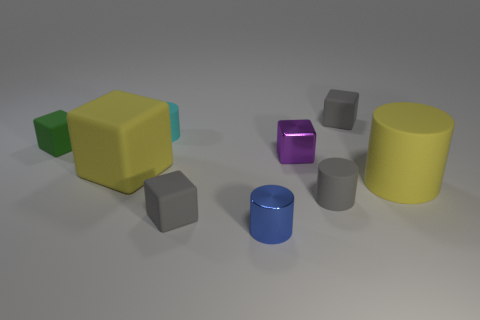There is a matte object that is the same color as the large block; what is its shape?
Your response must be concise. Cylinder. The block that is the same color as the big cylinder is what size?
Your answer should be compact. Large. There is a yellow rubber object on the right side of the cyan matte cylinder; what number of small gray rubber objects are behind it?
Your answer should be compact. 1. Is the shape of the purple object the same as the green object?
Make the answer very short. Yes. The blue thing that is the same shape as the tiny cyan object is what size?
Make the answer very short. Small. The rubber thing behind the small cylinder behind the big matte cylinder is what shape?
Provide a short and direct response. Cube. What is the size of the blue shiny cylinder?
Your response must be concise. Small. What shape is the green rubber object?
Your response must be concise. Cube. Do the cyan object and the large object that is in front of the large yellow rubber cube have the same shape?
Your answer should be compact. Yes. Is the shape of the small gray thing that is behind the small green matte block the same as  the cyan object?
Keep it short and to the point. No. 